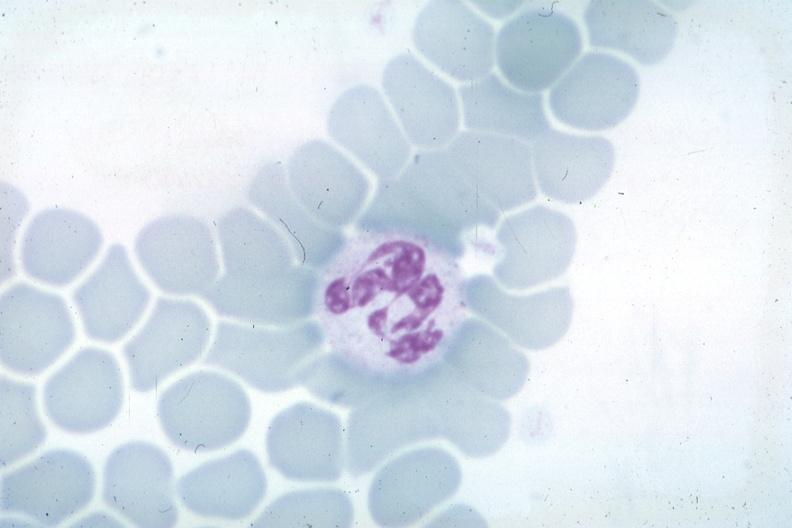what is present?
Answer the question using a single word or phrase. Blood 